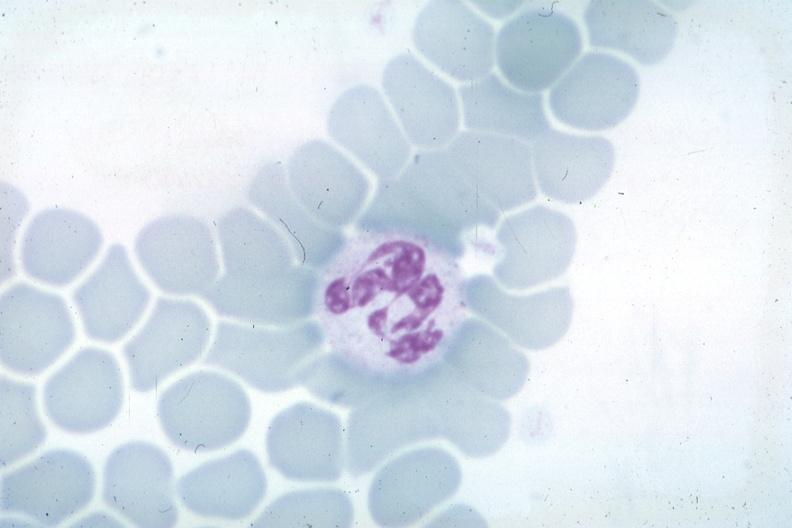what is present?
Answer the question using a single word or phrase. Blood 